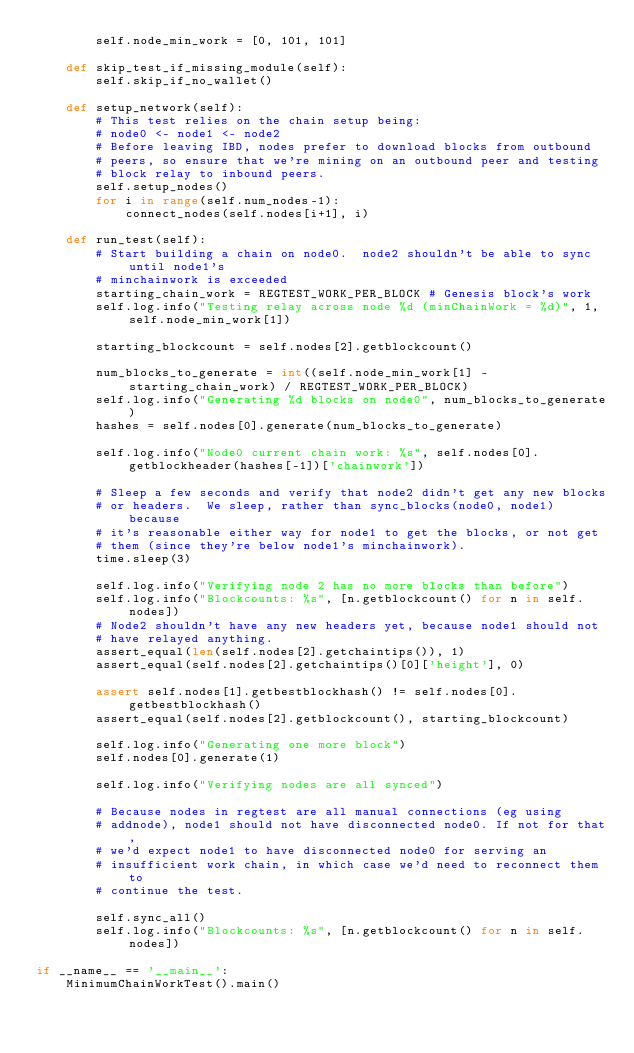<code> <loc_0><loc_0><loc_500><loc_500><_Python_>        self.node_min_work = [0, 101, 101]

    def skip_test_if_missing_module(self):
        self.skip_if_no_wallet()

    def setup_network(self):
        # This test relies on the chain setup being:
        # node0 <- node1 <- node2
        # Before leaving IBD, nodes prefer to download blocks from outbound
        # peers, so ensure that we're mining on an outbound peer and testing
        # block relay to inbound peers.
        self.setup_nodes()
        for i in range(self.num_nodes-1):
            connect_nodes(self.nodes[i+1], i)

    def run_test(self):
        # Start building a chain on node0.  node2 shouldn't be able to sync until node1's
        # minchainwork is exceeded
        starting_chain_work = REGTEST_WORK_PER_BLOCK # Genesis block's work
        self.log.info("Testing relay across node %d (minChainWork = %d)", 1, self.node_min_work[1])

        starting_blockcount = self.nodes[2].getblockcount()

        num_blocks_to_generate = int((self.node_min_work[1] - starting_chain_work) / REGTEST_WORK_PER_BLOCK)
        self.log.info("Generating %d blocks on node0", num_blocks_to_generate)
        hashes = self.nodes[0].generate(num_blocks_to_generate)

        self.log.info("Node0 current chain work: %s", self.nodes[0].getblockheader(hashes[-1])['chainwork'])

        # Sleep a few seconds and verify that node2 didn't get any new blocks
        # or headers.  We sleep, rather than sync_blocks(node0, node1) because
        # it's reasonable either way for node1 to get the blocks, or not get
        # them (since they're below node1's minchainwork).
        time.sleep(3)

        self.log.info("Verifying node 2 has no more blocks than before")
        self.log.info("Blockcounts: %s", [n.getblockcount() for n in self.nodes])
        # Node2 shouldn't have any new headers yet, because node1 should not
        # have relayed anything.
        assert_equal(len(self.nodes[2].getchaintips()), 1)
        assert_equal(self.nodes[2].getchaintips()[0]['height'], 0)

        assert self.nodes[1].getbestblockhash() != self.nodes[0].getbestblockhash()
        assert_equal(self.nodes[2].getblockcount(), starting_blockcount)

        self.log.info("Generating one more block")
        self.nodes[0].generate(1)

        self.log.info("Verifying nodes are all synced")

        # Because nodes in regtest are all manual connections (eg using
        # addnode), node1 should not have disconnected node0. If not for that,
        # we'd expect node1 to have disconnected node0 for serving an
        # insufficient work chain, in which case we'd need to reconnect them to
        # continue the test.

        self.sync_all()
        self.log.info("Blockcounts: %s", [n.getblockcount() for n in self.nodes])

if __name__ == '__main__':
    MinimumChainWorkTest().main()
</code> 